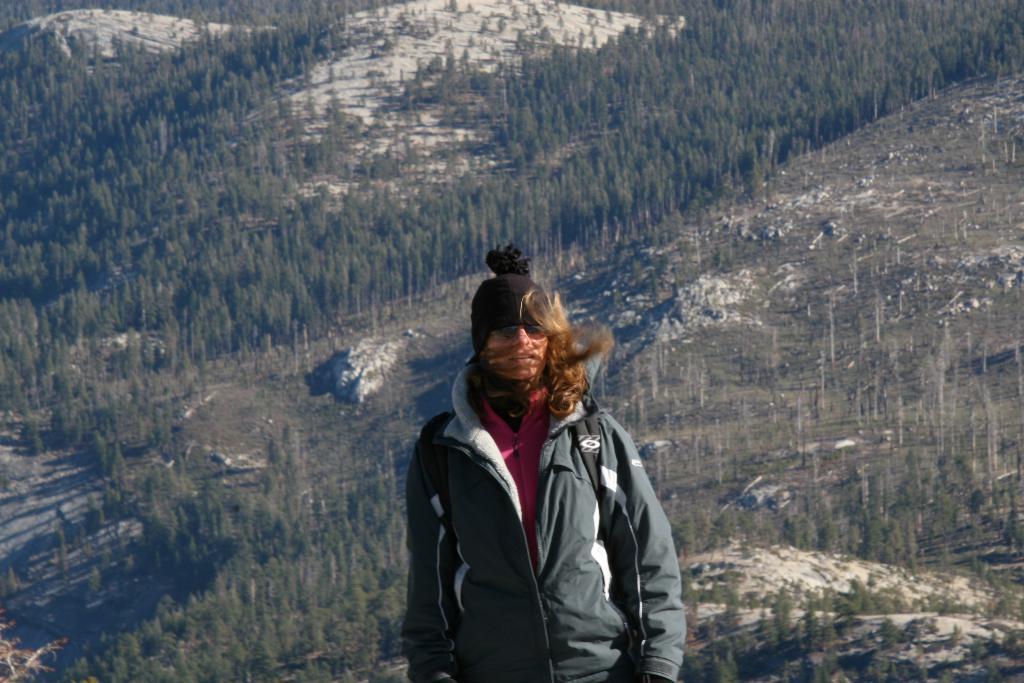Can you describe this image briefly? In the center of the image, we can see a lady wearing a coat and a cap. In the background, there are hills and we can see trees. 